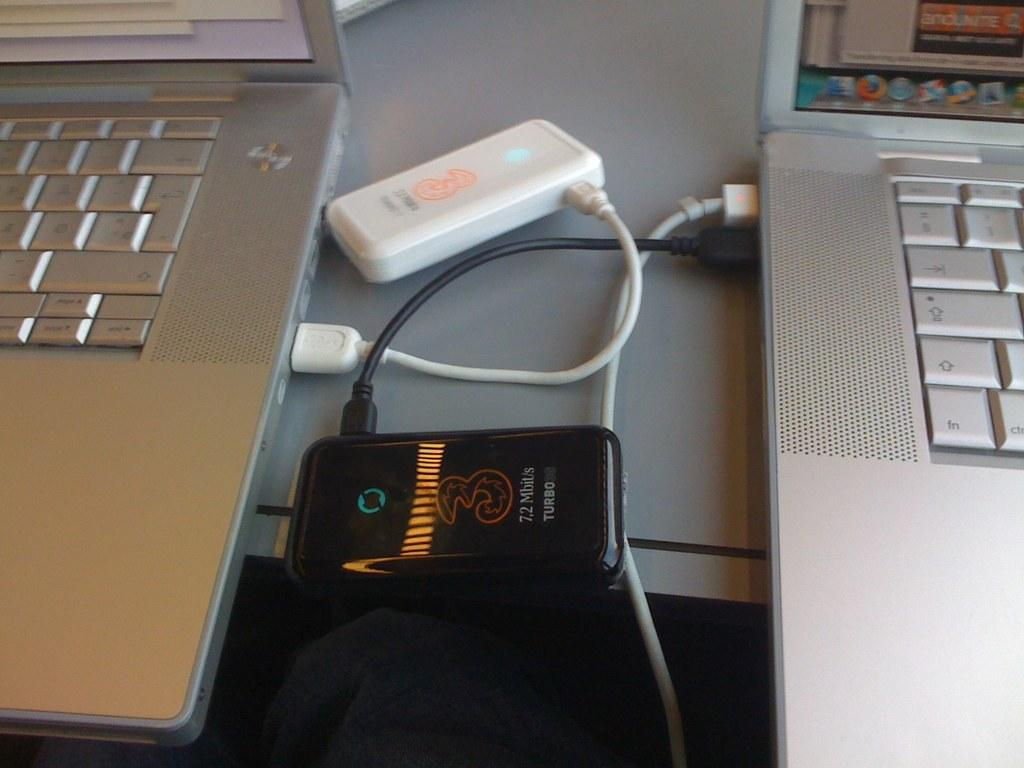Provide a one-sentence caption for the provided image. A black device displaying internet speed of 7,2 Mbit/s turbo 30. 